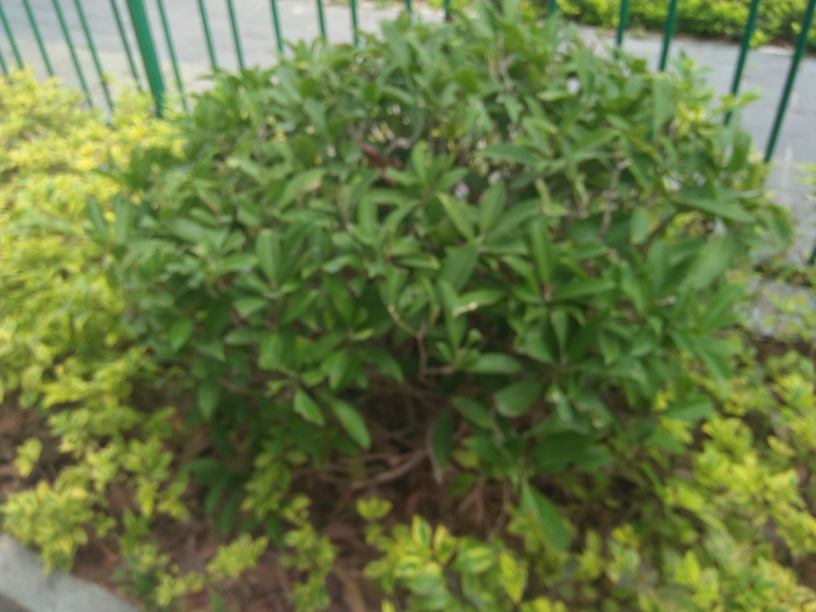Can you describe the focus and sharpness of this photo? The photo appears to be out of focus, with the overall image lacking sharpness. This blurriness prevents a clear view of the finer details of the plants and foliage within the frame. 